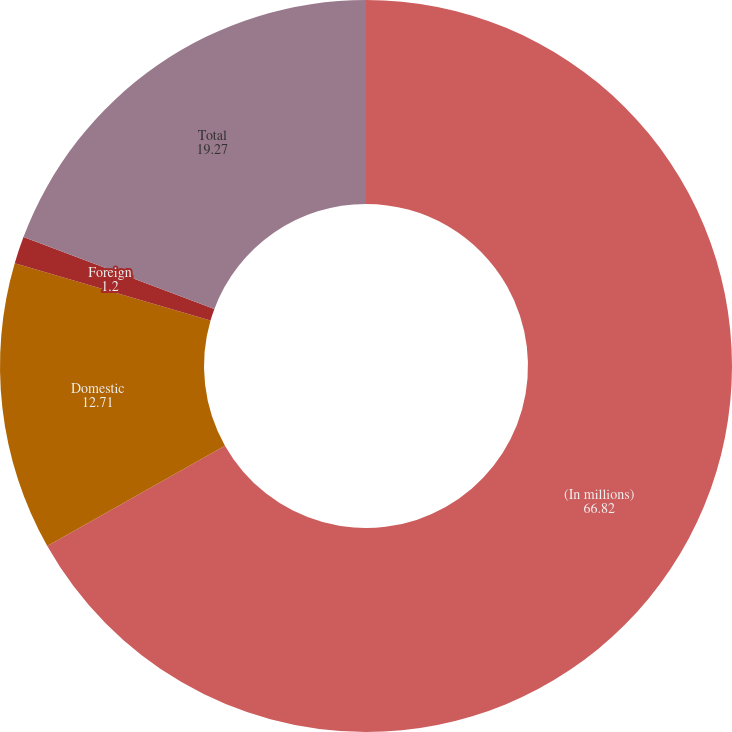<chart> <loc_0><loc_0><loc_500><loc_500><pie_chart><fcel>(In millions)<fcel>Domestic<fcel>Foreign<fcel>Total<nl><fcel>66.82%<fcel>12.71%<fcel>1.2%<fcel>19.27%<nl></chart> 